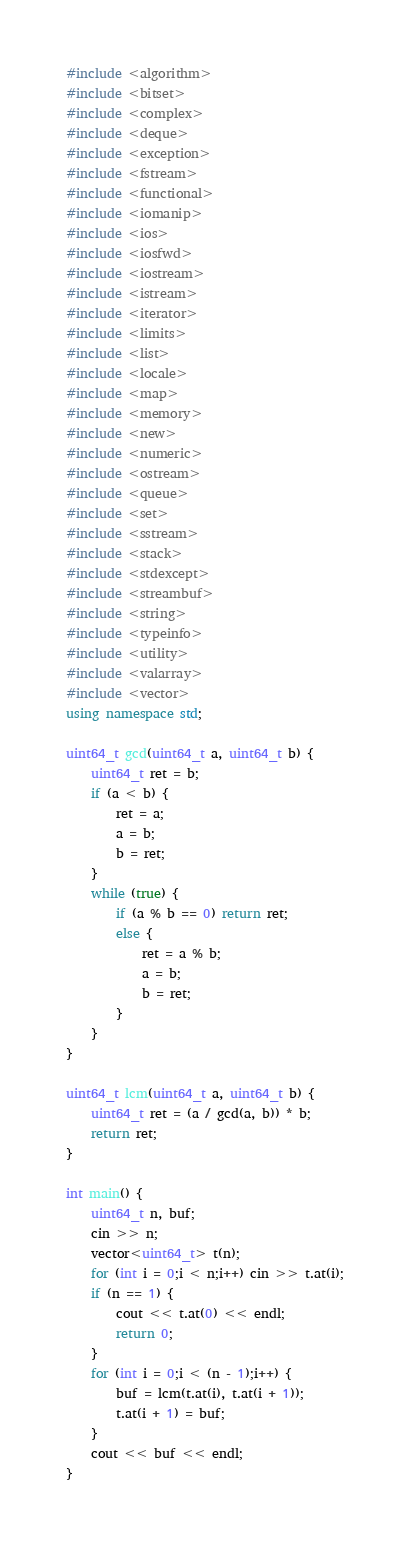<code> <loc_0><loc_0><loc_500><loc_500><_C++_>#include <algorithm>
#include <bitset>
#include <complex>
#include <deque>
#include <exception>
#include <fstream>
#include <functional>
#include <iomanip>
#include <ios>
#include <iosfwd>
#include <iostream>
#include <istream>
#include <iterator>
#include <limits>
#include <list>
#include <locale>
#include <map>
#include <memory>
#include <new>
#include <numeric>
#include <ostream>
#include <queue>
#include <set>
#include <sstream>
#include <stack>
#include <stdexcept>
#include <streambuf>
#include <string>
#include <typeinfo>
#include <utility>
#include <valarray>
#include <vector>
using namespace std;

uint64_t gcd(uint64_t a, uint64_t b) {
    uint64_t ret = b;
    if (a < b) {
        ret = a;
        a = b;
        b = ret;
    }
    while (true) {
        if (a % b == 0) return ret;
        else {
            ret = a % b;
            a = b;
            b = ret;
        }
    }
}

uint64_t lcm(uint64_t a, uint64_t b) {
    uint64_t ret = (a / gcd(a, b)) * b;
    return ret;
}

int main() {
    uint64_t n, buf;
    cin >> n;
    vector<uint64_t> t(n);
    for (int i = 0;i < n;i++) cin >> t.at(i);
    if (n == 1) {
        cout << t.at(0) << endl;
        return 0;
    }
    for (int i = 0;i < (n - 1);i++) {
        buf = lcm(t.at(i), t.at(i + 1));
        t.at(i + 1) = buf;
    }
    cout << buf << endl;
}</code> 